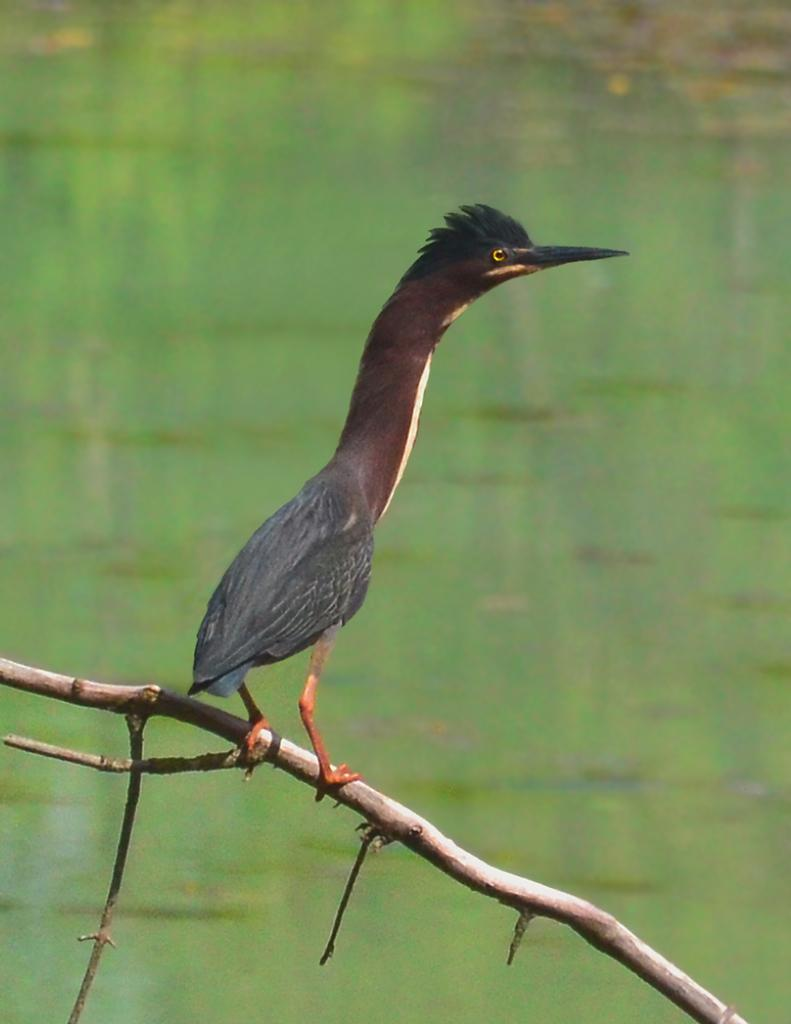What type of animal can be seen in the image? There is a bird in the image. What is the bird doing in the image? The bird is standing on something. What can be seen in the background of the image? There is water visible in the background of the image. What type of brass instrument is the bird playing in the image? There is no brass instrument present in the image, and the bird is not playing any instrument. 